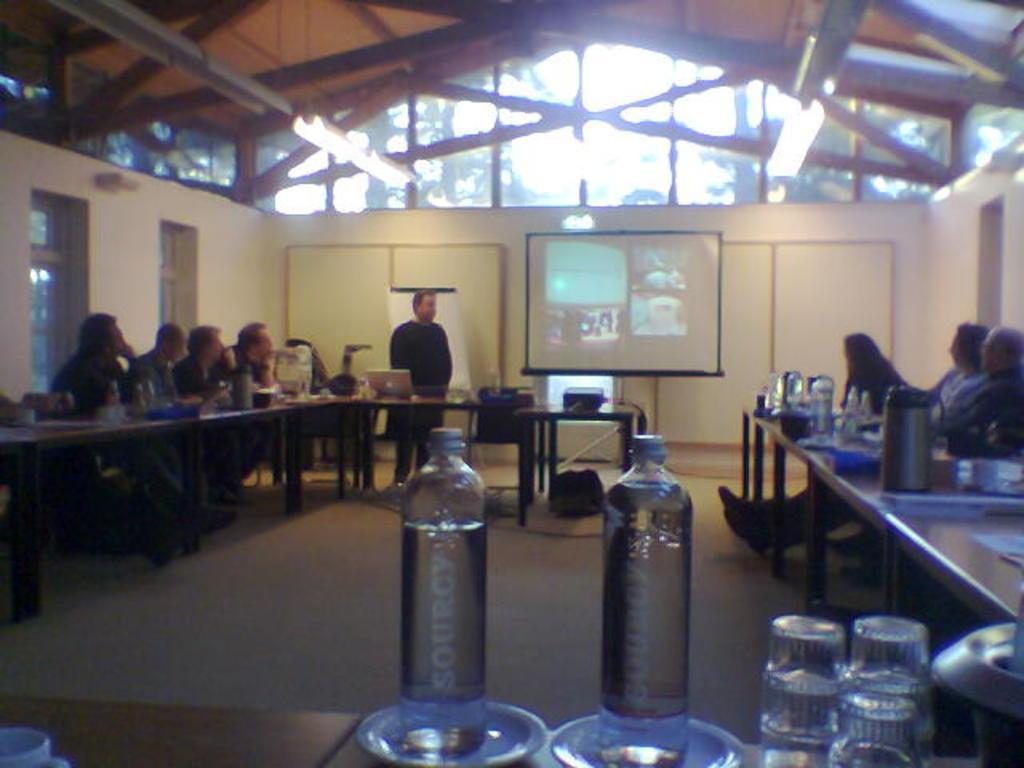Please provide a concise description of this image. In this image i can see a group of people who are sitting on the chair in front of a table and a man is standing. On the table we have few objects on it. I can also see there is a projector screen. 